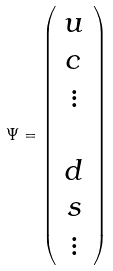<formula> <loc_0><loc_0><loc_500><loc_500>\Psi = \left ( \begin{array} { c } u \\ c \\ \vdots \\ \\ d \\ s \\ \vdots \end{array} \right )</formula> 